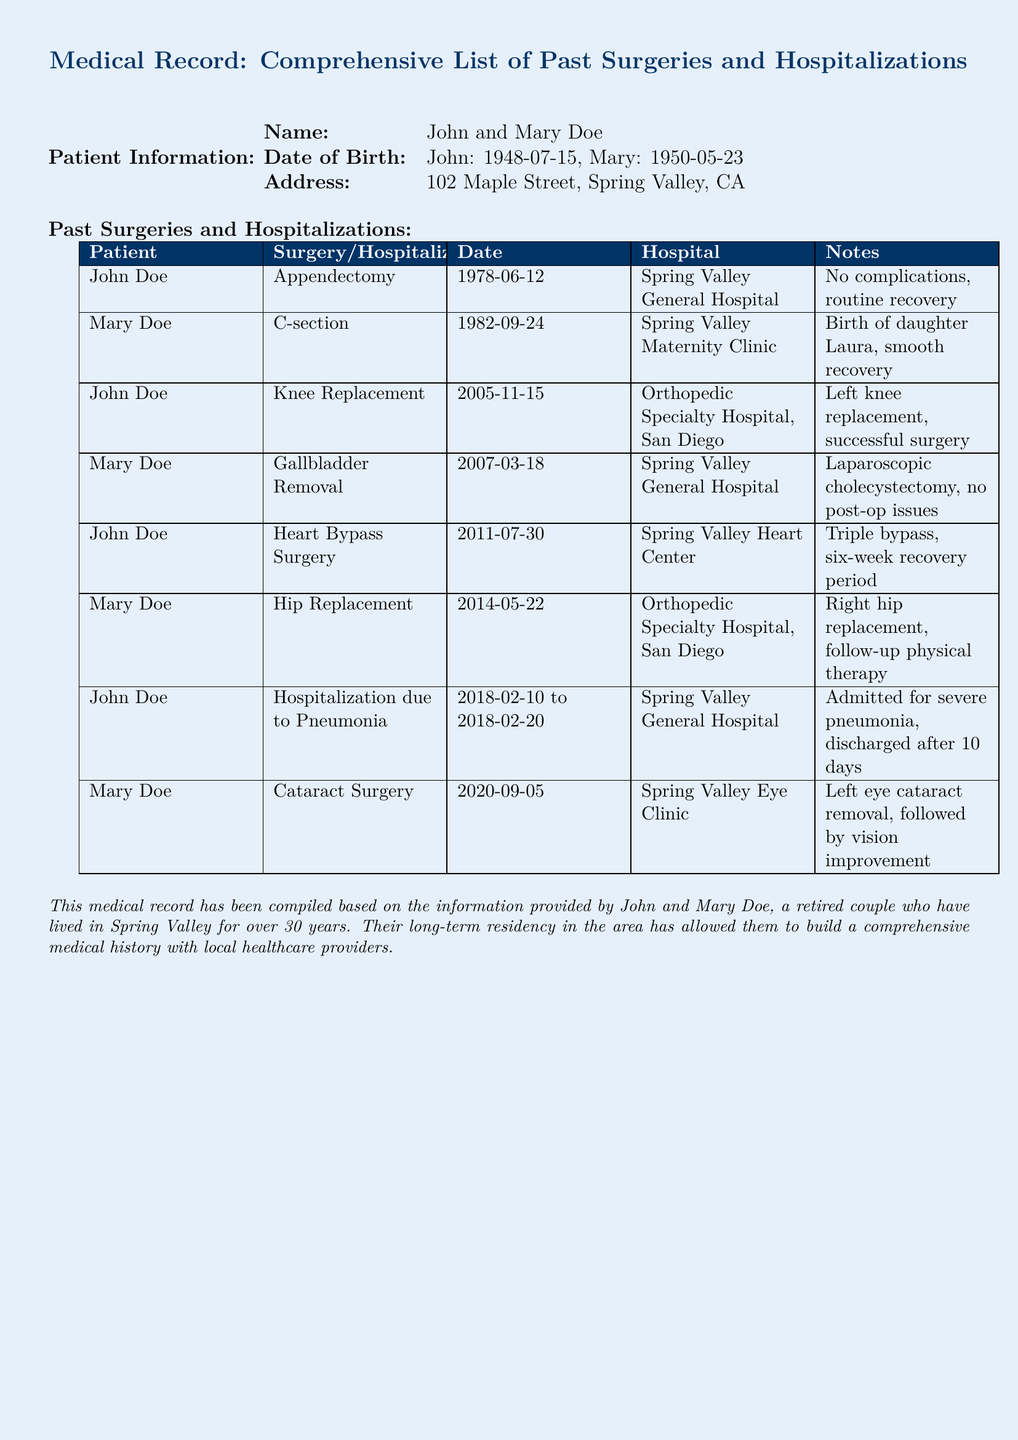What surgery did John Doe have on June 12, 1978? John Doe had an appendectomy on that date, as listed under his past surgeries.
Answer: Appendectomy When was Mary Doe's gallbladder removal surgery? The date of Mary Doe's gallbladder removal surgery is specified in the table as March 18, 2007.
Answer: 2007-03-18 Which hospital performed John's heart bypass surgery? The document lists Spring Valley Heart Center as the facility where John's heart bypass surgery was performed.
Answer: Spring Valley Heart Center How many days was John hospitalized for pneumonia? The hospitalization period for pneumonia lasted from February 10 to February 20, 2018, totaling ten days.
Answer: 10 days What type of surgery did Mary Doe have in September 2020? The document indicates that Mary Doe underwent cataract surgery in that month.
Answer: Cataract Surgery Which surgery did John Doe have that was performed in San Diego? The knee replacement and the heart bypass surgeries listed were both performed in San Diego, but specifically the knee replacement in November 2005 is noted.
Answer: Knee Replacement What was the main health issue that led to John's hospitalization in February 2018? The main health issue that led to John's hospitalization was pneumonia, as indicated in the document.
Answer: Pneumonia How many surgeries has Mary Doe had listed in the document? Mary Doe has a total of four surgeries listed in the document.
Answer: 4 